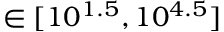Convert formula to latex. <formula><loc_0><loc_0><loc_500><loc_500>\in [ 1 0 ^ { 1 . 5 } , 1 0 ^ { 4 . 5 } ]</formula> 